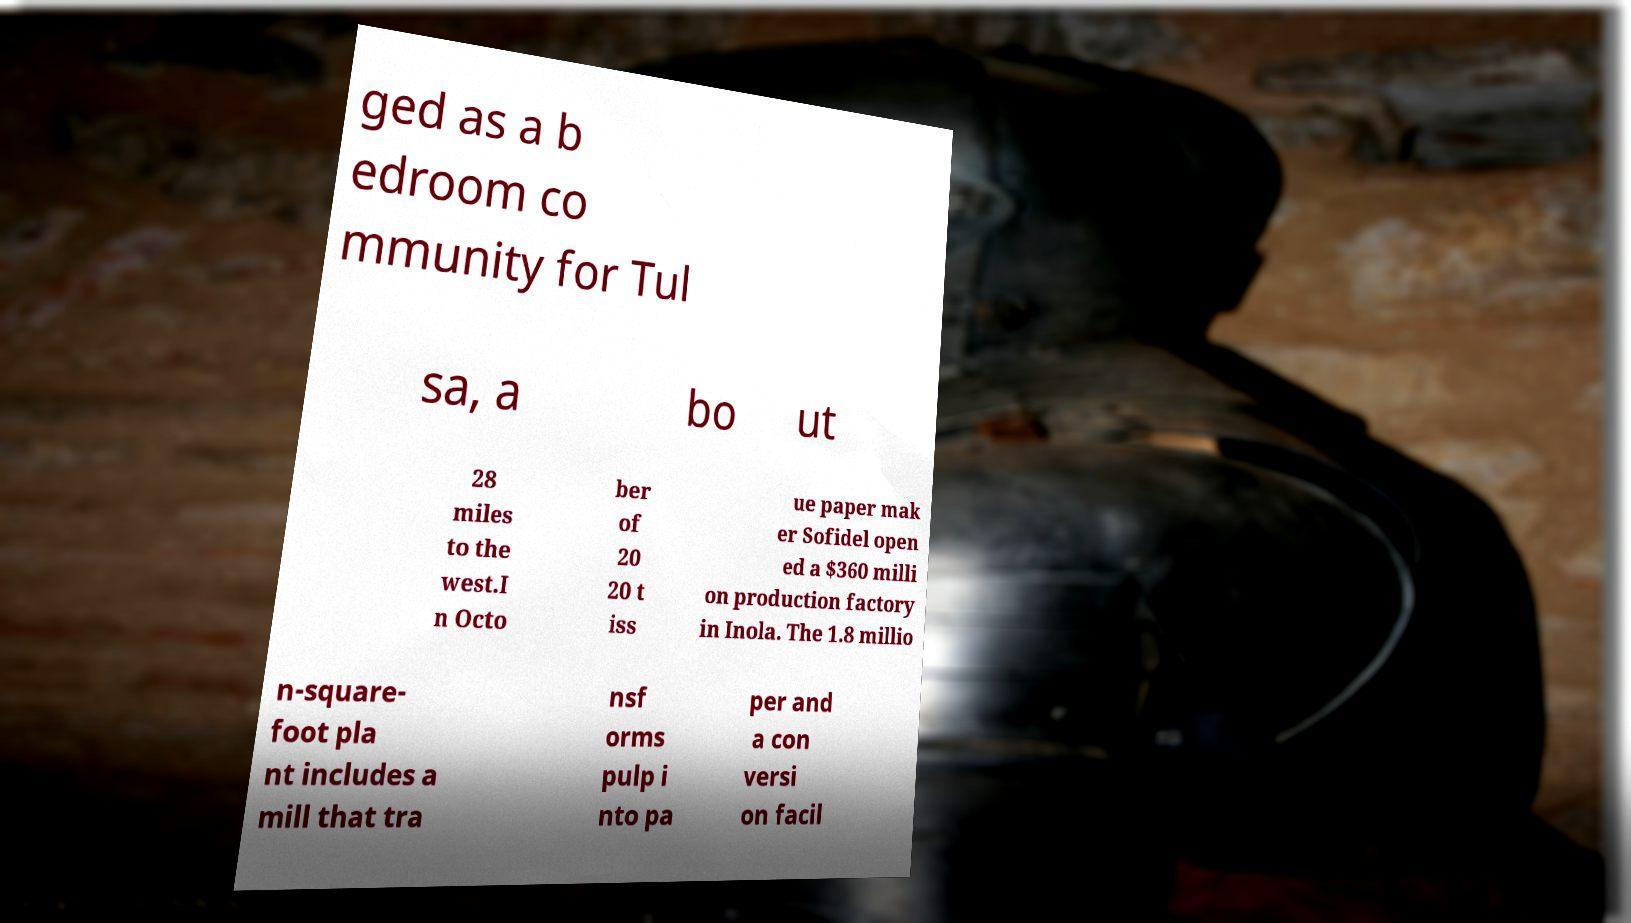For documentation purposes, I need the text within this image transcribed. Could you provide that? ged as a b edroom co mmunity for Tul sa, a bo ut 28 miles to the west.I n Octo ber of 20 20 t iss ue paper mak er Sofidel open ed a $360 milli on production factory in Inola. The 1.8 millio n-square- foot pla nt includes a mill that tra nsf orms pulp i nto pa per and a con versi on facil 